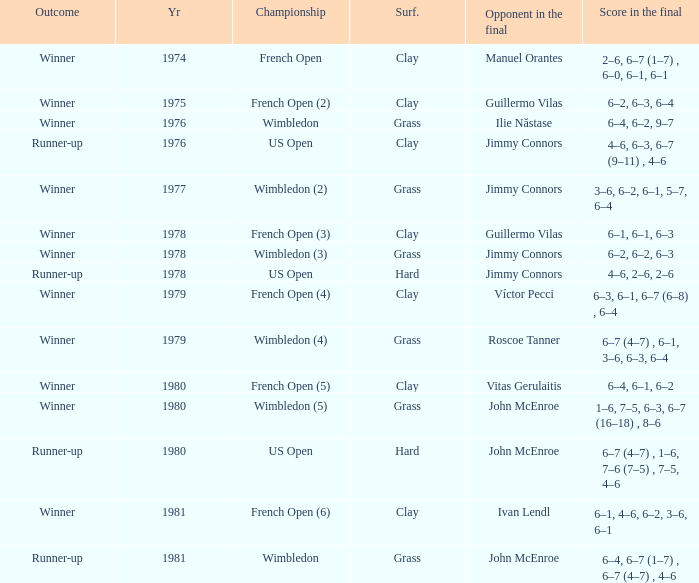Parse the table in full. {'header': ['Outcome', 'Yr', 'Championship', 'Surf.', 'Opponent in the final', 'Score in the final'], 'rows': [['Winner', '1974', 'French Open', 'Clay', 'Manuel Orantes', '2–6, 6–7 (1–7) , 6–0, 6–1, 6–1'], ['Winner', '1975', 'French Open (2)', 'Clay', 'Guillermo Vilas', '6–2, 6–3, 6–4'], ['Winner', '1976', 'Wimbledon', 'Grass', 'Ilie Năstase', '6–4, 6–2, 9–7'], ['Runner-up', '1976', 'US Open', 'Clay', 'Jimmy Connors', '4–6, 6–3, 6–7 (9–11) , 4–6'], ['Winner', '1977', 'Wimbledon (2)', 'Grass', 'Jimmy Connors', '3–6, 6–2, 6–1, 5–7, 6–4'], ['Winner', '1978', 'French Open (3)', 'Clay', 'Guillermo Vilas', '6–1, 6–1, 6–3'], ['Winner', '1978', 'Wimbledon (3)', 'Grass', 'Jimmy Connors', '6–2, 6–2, 6–3'], ['Runner-up', '1978', 'US Open', 'Hard', 'Jimmy Connors', '4–6, 2–6, 2–6'], ['Winner', '1979', 'French Open (4)', 'Clay', 'Víctor Pecci', '6–3, 6–1, 6–7 (6–8) , 6–4'], ['Winner', '1979', 'Wimbledon (4)', 'Grass', 'Roscoe Tanner', '6–7 (4–7) , 6–1, 3–6, 6–3, 6–4'], ['Winner', '1980', 'French Open (5)', 'Clay', 'Vitas Gerulaitis', '6–4, 6–1, 6–2'], ['Winner', '1980', 'Wimbledon (5)', 'Grass', 'John McEnroe', '1–6, 7–5, 6–3, 6–7 (16–18) , 8–6'], ['Runner-up', '1980', 'US Open', 'Hard', 'John McEnroe', '6–7 (4–7) , 1–6, 7–6 (7–5) , 7–5, 4–6'], ['Winner', '1981', 'French Open (6)', 'Clay', 'Ivan Lendl', '6–1, 4–6, 6–2, 3–6, 6–1'], ['Runner-up', '1981', 'Wimbledon', 'Grass', 'John McEnroe', '6–4, 6–7 (1–7) , 6–7 (4–7) , 4–6']]} What is every surface with a score in the final of 6–4, 6–7 (1–7) , 6–7 (4–7) , 4–6? Grass. 